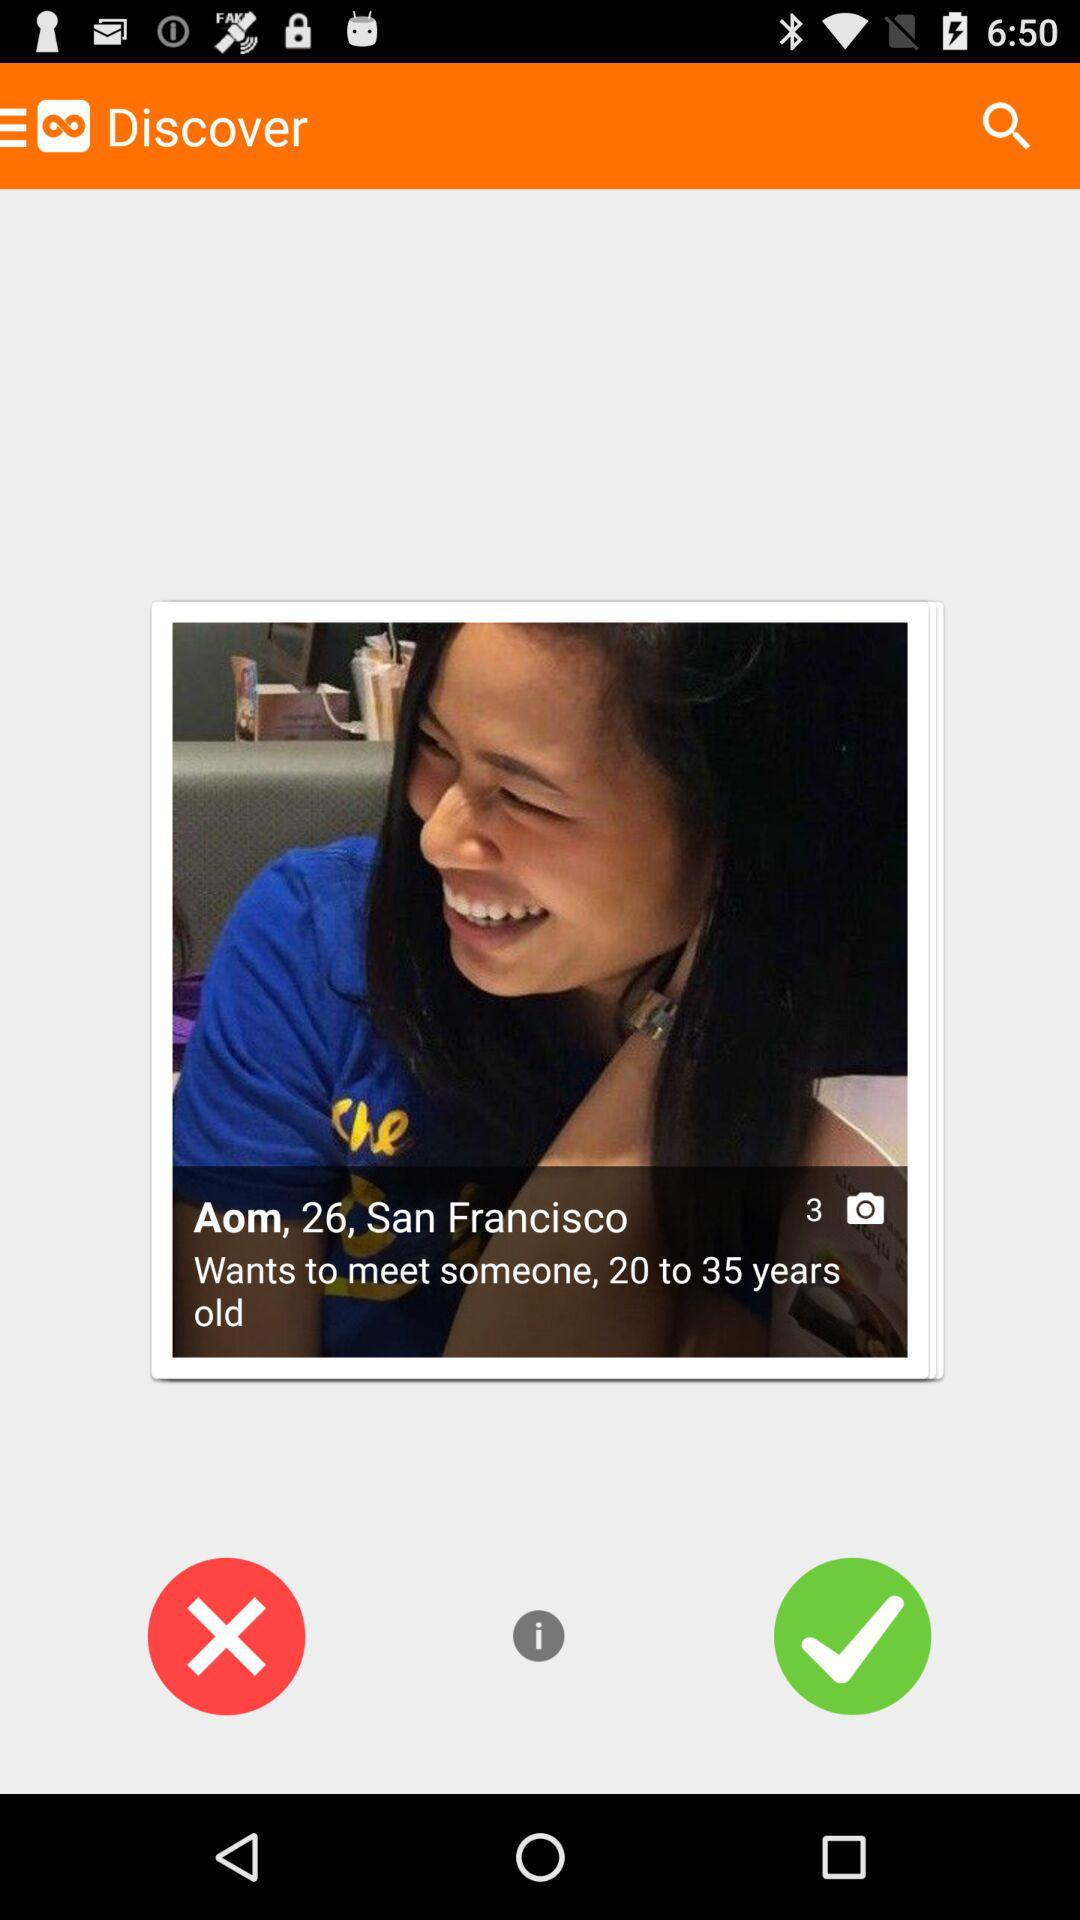How many years older is Aom than the minimum age she is willing to meet?
Answer the question using a single word or phrase. 6 